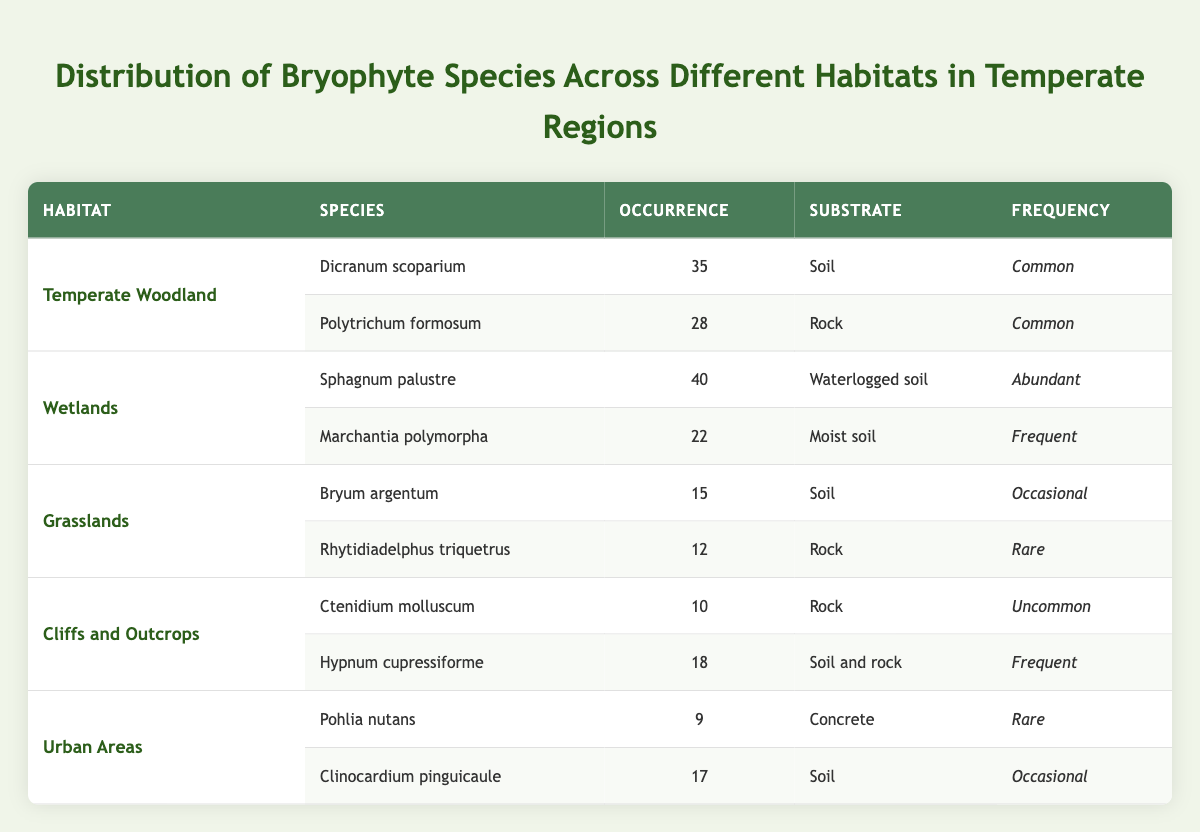What is the habitat with the highest occurrence of bryophyte species? By reviewing the table, Wetlands show the highest occurrence with a total of 62 (40 for Sphagnum palustre and 22 for Marchantia polymorpha).
Answer: Wetlands How many species of bryophytes are recorded in Grasslands? The table shows 2 species recorded in Grasslands: Bryum argentum and Rhytidiadelphus triquetrus.
Answer: 2 Is Hypnum cupressiforme found in soil or rock? The table indicates that Hypnum cupressiforme is found in "Soil and rock."
Answer: Yes What is the average occurrence of bryophyte species in Urban Areas? The occurrences in Urban Areas are 9 for Pohlia nutans and 17 for Clinocardium pinguicaule. To find the average, sum these (9 + 17 = 26) and divide by 2 species. So, 26/2 = 13.
Answer: 13 Which bryophyte species is recorded as "Abundant" in Wetlands? The table shows that Sphagnum palustre is recorded as "Abundant" in Wetlands.
Answer: Sphagnum palustre What is the difference between the occurrences of species in Temperate Woodland and Cliffs and Outcrops? In Temperate Woodland, the total occurrence is 63 (35 for Dicranum scoparium and 28 for Polytrichum formosum). In Cliffs and Outcrops, the total is 28 (10 for Ctenidium molluscum and 18 for Hypnum cupressiforme). The difference is 63 - 28 = 35.
Answer: 35 Is Marchantia polymorpha considered a "Rare" species? According to the table, Marchantia polymorpha is categorized as "Frequent," so it is not considered "Rare."
Answer: No What is the total occurrence of bryophyte species found on "Soil" substrate across all habitats? Summarizing occurrences for species on "Soil": 35 (Dicranum scoparium) + 15 (Bryum argentum) + 18 (Hypnum cupressiforme) + 17 (Clinocardium pinguicaule) = 85 in total.
Answer: 85 Which habitat has the rarest bryophyte species recorded? The table indicates that Grasslands have Rhytidiadelphus triquetrus listed as "Rare," which is the lowest frequency category presented.
Answer: Grasslands What species is recorded as having the highest occurrence across all habitats? By evaluating occurrences, Sphagnum palustre has the highest occurrence with 40, higher than any other species in any habitat.
Answer: Sphagnum palustre 